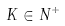<formula> <loc_0><loc_0><loc_500><loc_500>K \in N ^ { + }</formula> 